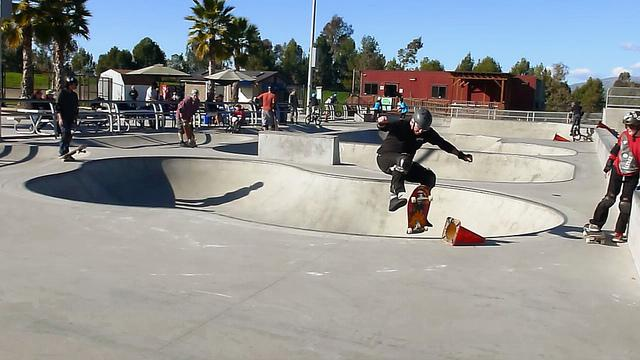Why have the skaters covered their heads? Please explain your reasoning. protection. Skateboarding presents risk to the head 